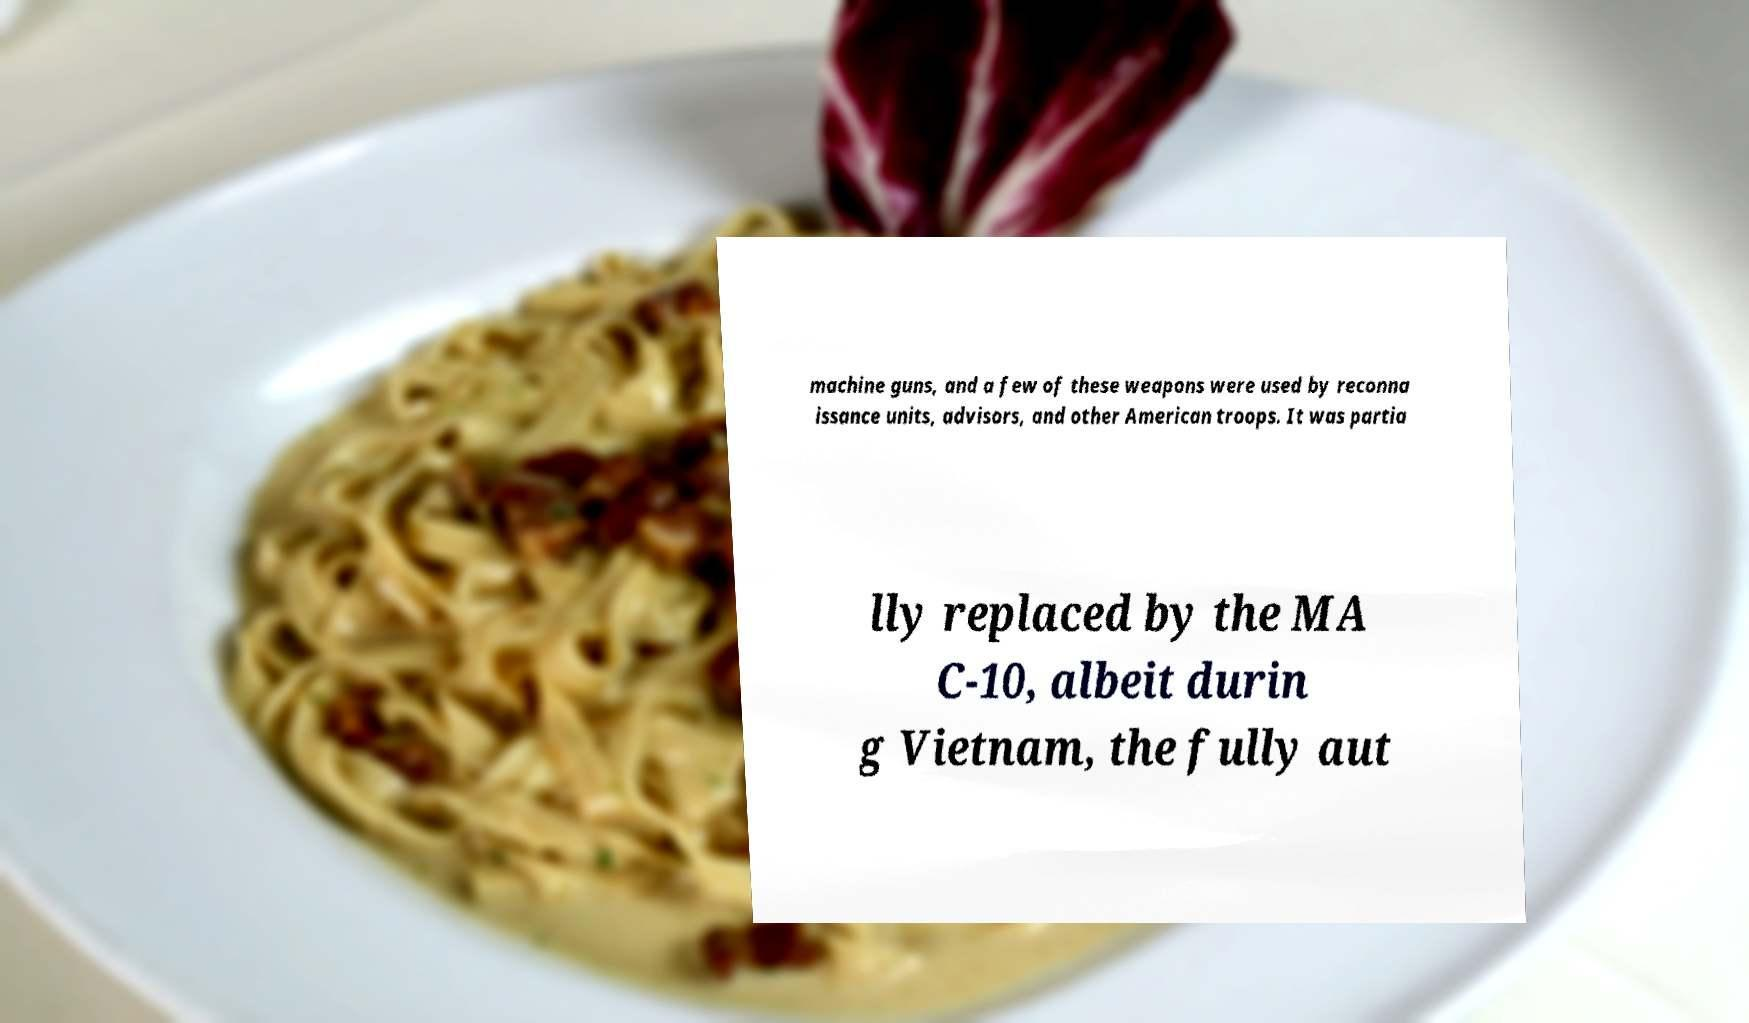For documentation purposes, I need the text within this image transcribed. Could you provide that? machine guns, and a few of these weapons were used by reconna issance units, advisors, and other American troops. It was partia lly replaced by the MA C-10, albeit durin g Vietnam, the fully aut 